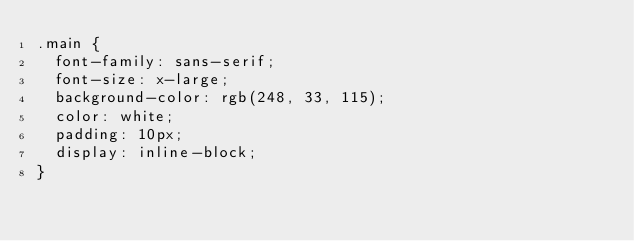<code> <loc_0><loc_0><loc_500><loc_500><_CSS_>.main {
  font-family: sans-serif;
  font-size: x-large;
  background-color: rgb(248, 33, 115);
  color: white;
  padding: 10px;
  display: inline-block;
}
</code> 